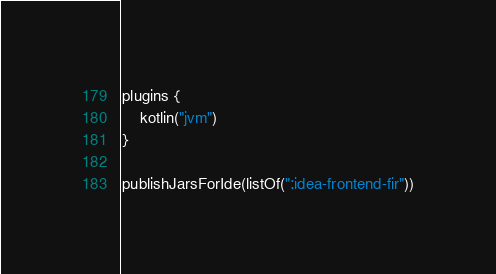Convert code to text. <code><loc_0><loc_0><loc_500><loc_500><_Kotlin_>plugins {
    kotlin("jvm")
}

publishJarsForIde(listOf(":idea-frontend-fir"))
</code> 